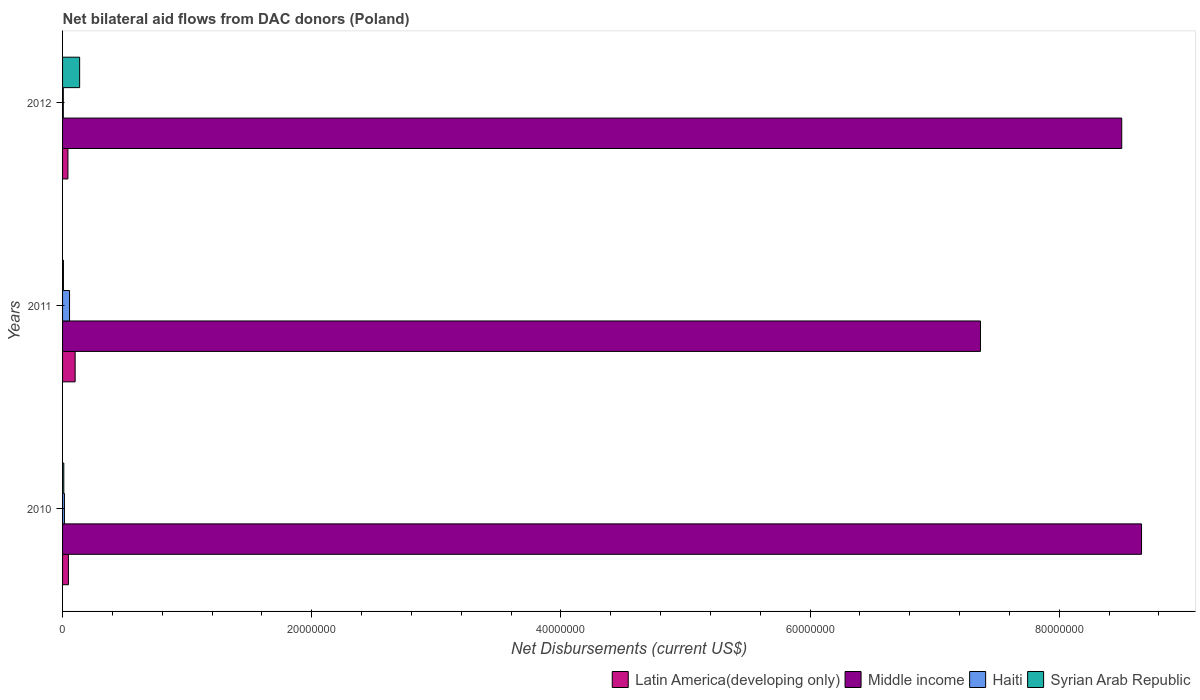How many different coloured bars are there?
Your answer should be compact. 4. How many groups of bars are there?
Your answer should be compact. 3. Are the number of bars per tick equal to the number of legend labels?
Provide a short and direct response. Yes. How many bars are there on the 3rd tick from the top?
Your response must be concise. 4. How many bars are there on the 1st tick from the bottom?
Your answer should be compact. 4. In how many cases, is the number of bars for a given year not equal to the number of legend labels?
Provide a succinct answer. 0. What is the net bilateral aid flows in Middle income in 2010?
Give a very brief answer. 8.66e+07. Across all years, what is the maximum net bilateral aid flows in Middle income?
Your answer should be very brief. 8.66e+07. What is the total net bilateral aid flows in Latin America(developing only) in the graph?
Offer a terse response. 1.91e+06. What is the difference between the net bilateral aid flows in Middle income in 2010 and that in 2012?
Provide a succinct answer. 1.59e+06. What is the difference between the net bilateral aid flows in Syrian Arab Republic in 2010 and the net bilateral aid flows in Middle income in 2012?
Offer a terse response. -8.49e+07. What is the average net bilateral aid flows in Middle income per year?
Your response must be concise. 8.18e+07. What is the ratio of the net bilateral aid flows in Haiti in 2011 to that in 2012?
Offer a very short reply. 9.33. Is the difference between the net bilateral aid flows in Latin America(developing only) in 2010 and 2012 greater than the difference between the net bilateral aid flows in Haiti in 2010 and 2012?
Your answer should be compact. No. What is the difference between the highest and the second highest net bilateral aid flows in Syrian Arab Republic?
Provide a short and direct response. 1.27e+06. In how many years, is the net bilateral aid flows in Syrian Arab Republic greater than the average net bilateral aid flows in Syrian Arab Republic taken over all years?
Offer a very short reply. 1. What does the 4th bar from the bottom in 2011 represents?
Your response must be concise. Syrian Arab Republic. Is it the case that in every year, the sum of the net bilateral aid flows in Latin America(developing only) and net bilateral aid flows in Haiti is greater than the net bilateral aid flows in Middle income?
Give a very brief answer. No. How many bars are there?
Your response must be concise. 12. Are all the bars in the graph horizontal?
Keep it short and to the point. Yes. How many years are there in the graph?
Make the answer very short. 3. What is the difference between two consecutive major ticks on the X-axis?
Provide a succinct answer. 2.00e+07. Are the values on the major ticks of X-axis written in scientific E-notation?
Offer a very short reply. No. Does the graph contain any zero values?
Offer a terse response. No. Does the graph contain grids?
Your answer should be compact. No. How many legend labels are there?
Keep it short and to the point. 4. How are the legend labels stacked?
Your response must be concise. Horizontal. What is the title of the graph?
Offer a very short reply. Net bilateral aid flows from DAC donors (Poland). Does "Malaysia" appear as one of the legend labels in the graph?
Make the answer very short. No. What is the label or title of the X-axis?
Your response must be concise. Net Disbursements (current US$). What is the Net Disbursements (current US$) in Middle income in 2010?
Offer a terse response. 8.66e+07. What is the Net Disbursements (current US$) in Latin America(developing only) in 2011?
Provide a short and direct response. 1.01e+06. What is the Net Disbursements (current US$) in Middle income in 2011?
Your response must be concise. 7.37e+07. What is the Net Disbursements (current US$) of Haiti in 2011?
Ensure brevity in your answer.  5.60e+05. What is the Net Disbursements (current US$) of Syrian Arab Republic in 2011?
Your response must be concise. 7.00e+04. What is the Net Disbursements (current US$) of Latin America(developing only) in 2012?
Offer a terse response. 4.30e+05. What is the Net Disbursements (current US$) of Middle income in 2012?
Your answer should be compact. 8.50e+07. What is the Net Disbursements (current US$) of Haiti in 2012?
Make the answer very short. 6.00e+04. What is the Net Disbursements (current US$) in Syrian Arab Republic in 2012?
Offer a terse response. 1.37e+06. Across all years, what is the maximum Net Disbursements (current US$) in Latin America(developing only)?
Your answer should be very brief. 1.01e+06. Across all years, what is the maximum Net Disbursements (current US$) in Middle income?
Provide a succinct answer. 8.66e+07. Across all years, what is the maximum Net Disbursements (current US$) of Haiti?
Offer a terse response. 5.60e+05. Across all years, what is the maximum Net Disbursements (current US$) of Syrian Arab Republic?
Offer a very short reply. 1.37e+06. Across all years, what is the minimum Net Disbursements (current US$) of Middle income?
Provide a succinct answer. 7.37e+07. Across all years, what is the minimum Net Disbursements (current US$) of Syrian Arab Republic?
Your answer should be very brief. 7.00e+04. What is the total Net Disbursements (current US$) of Latin America(developing only) in the graph?
Ensure brevity in your answer.  1.91e+06. What is the total Net Disbursements (current US$) in Middle income in the graph?
Offer a very short reply. 2.45e+08. What is the total Net Disbursements (current US$) of Haiti in the graph?
Your response must be concise. 7.70e+05. What is the total Net Disbursements (current US$) of Syrian Arab Republic in the graph?
Offer a very short reply. 1.54e+06. What is the difference between the Net Disbursements (current US$) in Latin America(developing only) in 2010 and that in 2011?
Ensure brevity in your answer.  -5.40e+05. What is the difference between the Net Disbursements (current US$) of Middle income in 2010 and that in 2011?
Offer a very short reply. 1.29e+07. What is the difference between the Net Disbursements (current US$) in Haiti in 2010 and that in 2011?
Provide a succinct answer. -4.10e+05. What is the difference between the Net Disbursements (current US$) of Middle income in 2010 and that in 2012?
Offer a very short reply. 1.59e+06. What is the difference between the Net Disbursements (current US$) of Syrian Arab Republic in 2010 and that in 2012?
Provide a succinct answer. -1.27e+06. What is the difference between the Net Disbursements (current US$) in Latin America(developing only) in 2011 and that in 2012?
Give a very brief answer. 5.80e+05. What is the difference between the Net Disbursements (current US$) in Middle income in 2011 and that in 2012?
Provide a succinct answer. -1.13e+07. What is the difference between the Net Disbursements (current US$) in Syrian Arab Republic in 2011 and that in 2012?
Your response must be concise. -1.30e+06. What is the difference between the Net Disbursements (current US$) of Latin America(developing only) in 2010 and the Net Disbursements (current US$) of Middle income in 2011?
Keep it short and to the point. -7.32e+07. What is the difference between the Net Disbursements (current US$) of Latin America(developing only) in 2010 and the Net Disbursements (current US$) of Haiti in 2011?
Your answer should be very brief. -9.00e+04. What is the difference between the Net Disbursements (current US$) in Middle income in 2010 and the Net Disbursements (current US$) in Haiti in 2011?
Keep it short and to the point. 8.60e+07. What is the difference between the Net Disbursements (current US$) in Middle income in 2010 and the Net Disbursements (current US$) in Syrian Arab Republic in 2011?
Offer a terse response. 8.65e+07. What is the difference between the Net Disbursements (current US$) of Latin America(developing only) in 2010 and the Net Disbursements (current US$) of Middle income in 2012?
Your answer should be compact. -8.46e+07. What is the difference between the Net Disbursements (current US$) in Latin America(developing only) in 2010 and the Net Disbursements (current US$) in Haiti in 2012?
Ensure brevity in your answer.  4.10e+05. What is the difference between the Net Disbursements (current US$) in Latin America(developing only) in 2010 and the Net Disbursements (current US$) in Syrian Arab Republic in 2012?
Offer a terse response. -9.00e+05. What is the difference between the Net Disbursements (current US$) in Middle income in 2010 and the Net Disbursements (current US$) in Haiti in 2012?
Your answer should be compact. 8.66e+07. What is the difference between the Net Disbursements (current US$) in Middle income in 2010 and the Net Disbursements (current US$) in Syrian Arab Republic in 2012?
Provide a succinct answer. 8.52e+07. What is the difference between the Net Disbursements (current US$) of Haiti in 2010 and the Net Disbursements (current US$) of Syrian Arab Republic in 2012?
Keep it short and to the point. -1.22e+06. What is the difference between the Net Disbursements (current US$) in Latin America(developing only) in 2011 and the Net Disbursements (current US$) in Middle income in 2012?
Your response must be concise. -8.40e+07. What is the difference between the Net Disbursements (current US$) of Latin America(developing only) in 2011 and the Net Disbursements (current US$) of Haiti in 2012?
Give a very brief answer. 9.50e+05. What is the difference between the Net Disbursements (current US$) in Latin America(developing only) in 2011 and the Net Disbursements (current US$) in Syrian Arab Republic in 2012?
Your answer should be compact. -3.60e+05. What is the difference between the Net Disbursements (current US$) in Middle income in 2011 and the Net Disbursements (current US$) in Haiti in 2012?
Provide a short and direct response. 7.36e+07. What is the difference between the Net Disbursements (current US$) in Middle income in 2011 and the Net Disbursements (current US$) in Syrian Arab Republic in 2012?
Keep it short and to the point. 7.23e+07. What is the difference between the Net Disbursements (current US$) of Haiti in 2011 and the Net Disbursements (current US$) of Syrian Arab Republic in 2012?
Give a very brief answer. -8.10e+05. What is the average Net Disbursements (current US$) of Latin America(developing only) per year?
Offer a terse response. 6.37e+05. What is the average Net Disbursements (current US$) of Middle income per year?
Keep it short and to the point. 8.18e+07. What is the average Net Disbursements (current US$) of Haiti per year?
Provide a short and direct response. 2.57e+05. What is the average Net Disbursements (current US$) in Syrian Arab Republic per year?
Offer a terse response. 5.13e+05. In the year 2010, what is the difference between the Net Disbursements (current US$) in Latin America(developing only) and Net Disbursements (current US$) in Middle income?
Your response must be concise. -8.61e+07. In the year 2010, what is the difference between the Net Disbursements (current US$) of Middle income and Net Disbursements (current US$) of Haiti?
Keep it short and to the point. 8.65e+07. In the year 2010, what is the difference between the Net Disbursements (current US$) of Middle income and Net Disbursements (current US$) of Syrian Arab Republic?
Your response must be concise. 8.65e+07. In the year 2010, what is the difference between the Net Disbursements (current US$) of Haiti and Net Disbursements (current US$) of Syrian Arab Republic?
Your answer should be compact. 5.00e+04. In the year 2011, what is the difference between the Net Disbursements (current US$) of Latin America(developing only) and Net Disbursements (current US$) of Middle income?
Offer a very short reply. -7.27e+07. In the year 2011, what is the difference between the Net Disbursements (current US$) in Latin America(developing only) and Net Disbursements (current US$) in Haiti?
Provide a short and direct response. 4.50e+05. In the year 2011, what is the difference between the Net Disbursements (current US$) of Latin America(developing only) and Net Disbursements (current US$) of Syrian Arab Republic?
Provide a succinct answer. 9.40e+05. In the year 2011, what is the difference between the Net Disbursements (current US$) of Middle income and Net Disbursements (current US$) of Haiti?
Offer a terse response. 7.31e+07. In the year 2011, what is the difference between the Net Disbursements (current US$) of Middle income and Net Disbursements (current US$) of Syrian Arab Republic?
Your answer should be very brief. 7.36e+07. In the year 2012, what is the difference between the Net Disbursements (current US$) of Latin America(developing only) and Net Disbursements (current US$) of Middle income?
Your answer should be compact. -8.46e+07. In the year 2012, what is the difference between the Net Disbursements (current US$) in Latin America(developing only) and Net Disbursements (current US$) in Syrian Arab Republic?
Provide a succinct answer. -9.40e+05. In the year 2012, what is the difference between the Net Disbursements (current US$) of Middle income and Net Disbursements (current US$) of Haiti?
Give a very brief answer. 8.50e+07. In the year 2012, what is the difference between the Net Disbursements (current US$) of Middle income and Net Disbursements (current US$) of Syrian Arab Republic?
Provide a succinct answer. 8.36e+07. In the year 2012, what is the difference between the Net Disbursements (current US$) in Haiti and Net Disbursements (current US$) in Syrian Arab Republic?
Keep it short and to the point. -1.31e+06. What is the ratio of the Net Disbursements (current US$) of Latin America(developing only) in 2010 to that in 2011?
Give a very brief answer. 0.47. What is the ratio of the Net Disbursements (current US$) of Middle income in 2010 to that in 2011?
Your response must be concise. 1.18. What is the ratio of the Net Disbursements (current US$) of Haiti in 2010 to that in 2011?
Provide a succinct answer. 0.27. What is the ratio of the Net Disbursements (current US$) in Syrian Arab Republic in 2010 to that in 2011?
Keep it short and to the point. 1.43. What is the ratio of the Net Disbursements (current US$) of Latin America(developing only) in 2010 to that in 2012?
Your answer should be very brief. 1.09. What is the ratio of the Net Disbursements (current US$) of Middle income in 2010 to that in 2012?
Offer a terse response. 1.02. What is the ratio of the Net Disbursements (current US$) in Haiti in 2010 to that in 2012?
Provide a short and direct response. 2.5. What is the ratio of the Net Disbursements (current US$) in Syrian Arab Republic in 2010 to that in 2012?
Your answer should be compact. 0.07. What is the ratio of the Net Disbursements (current US$) in Latin America(developing only) in 2011 to that in 2012?
Offer a very short reply. 2.35. What is the ratio of the Net Disbursements (current US$) of Middle income in 2011 to that in 2012?
Give a very brief answer. 0.87. What is the ratio of the Net Disbursements (current US$) in Haiti in 2011 to that in 2012?
Offer a very short reply. 9.33. What is the ratio of the Net Disbursements (current US$) in Syrian Arab Republic in 2011 to that in 2012?
Ensure brevity in your answer.  0.05. What is the difference between the highest and the second highest Net Disbursements (current US$) of Latin America(developing only)?
Ensure brevity in your answer.  5.40e+05. What is the difference between the highest and the second highest Net Disbursements (current US$) in Middle income?
Ensure brevity in your answer.  1.59e+06. What is the difference between the highest and the second highest Net Disbursements (current US$) in Haiti?
Offer a very short reply. 4.10e+05. What is the difference between the highest and the second highest Net Disbursements (current US$) in Syrian Arab Republic?
Your answer should be compact. 1.27e+06. What is the difference between the highest and the lowest Net Disbursements (current US$) of Latin America(developing only)?
Provide a short and direct response. 5.80e+05. What is the difference between the highest and the lowest Net Disbursements (current US$) of Middle income?
Your answer should be very brief. 1.29e+07. What is the difference between the highest and the lowest Net Disbursements (current US$) of Syrian Arab Republic?
Ensure brevity in your answer.  1.30e+06. 